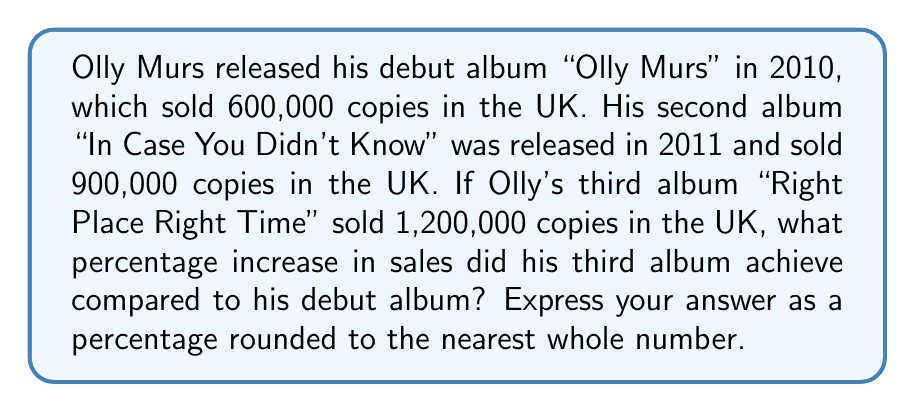Provide a solution to this math problem. To solve this problem, we'll use ratios and proportions to calculate the percentage increase in sales from Olly Murs' first album to his third album.

Let's define our variables:
$A_1$ = Sales of the first album = 600,000
$A_3$ = Sales of the third album = 1,200,000

Step 1: Calculate the difference in sales between the third and first albums.
Difference = $A_3 - A_1 = 1,200,000 - 600,000 = 600,000$

Step 2: Set up a proportion to calculate the percentage increase.
$$\frac{\text{Increase}}{\text{Original}} = \frac{\text{Percentage increase}}{100\%}$$

$$\frac{600,000}{600,000} = \frac{x}{100\%}$$

Step 3: Solve for x (the percentage increase).
$$1 = \frac{x}{100\%}$$
$$x = 1 \times 100\% = 100\%$$

Therefore, the percentage increase from the first album to the third album is 100%.
Answer: 100% 